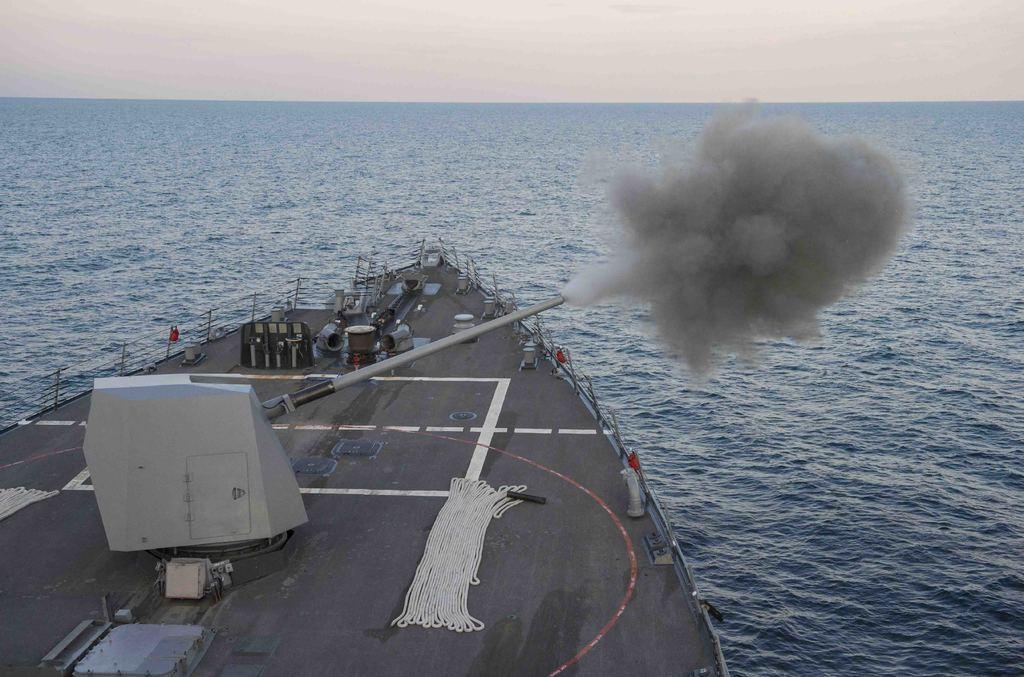Describe this image in one or two sentences. This picture shows a ship in the water and we see a metal pipe releasing smoke and we see a cloudy sky. 